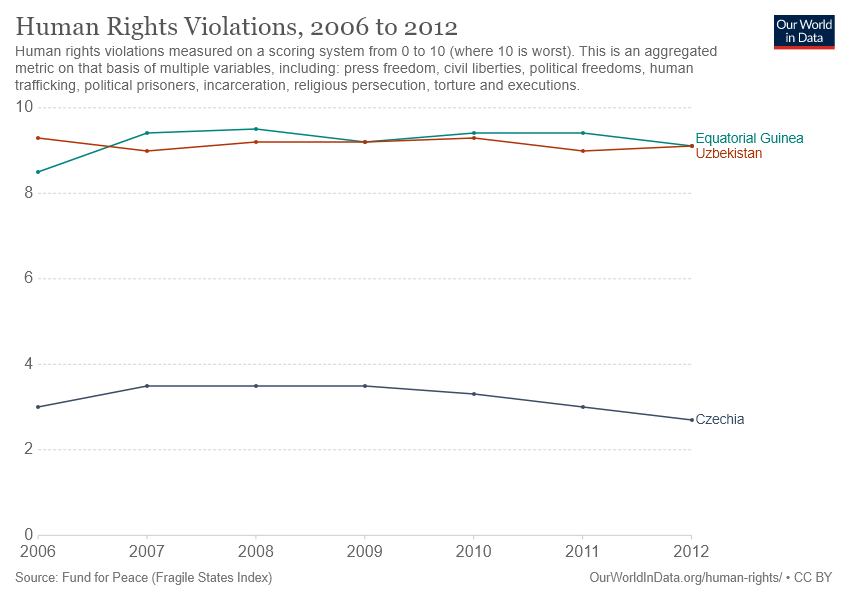Indicate a few pertinent items in this graphic. Uzbekistan and Equatorial Guinea have crossed paths three times in their relationship. Czechia's human rights violation score in 2006 was greater than 2, and yes, it was greater than 2. 